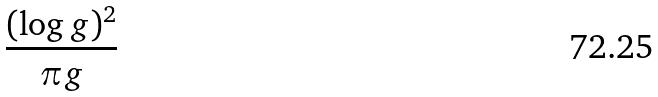Convert formula to latex. <formula><loc_0><loc_0><loc_500><loc_500>\frac { ( \log g ) ^ { 2 } } { \pi g }</formula> 